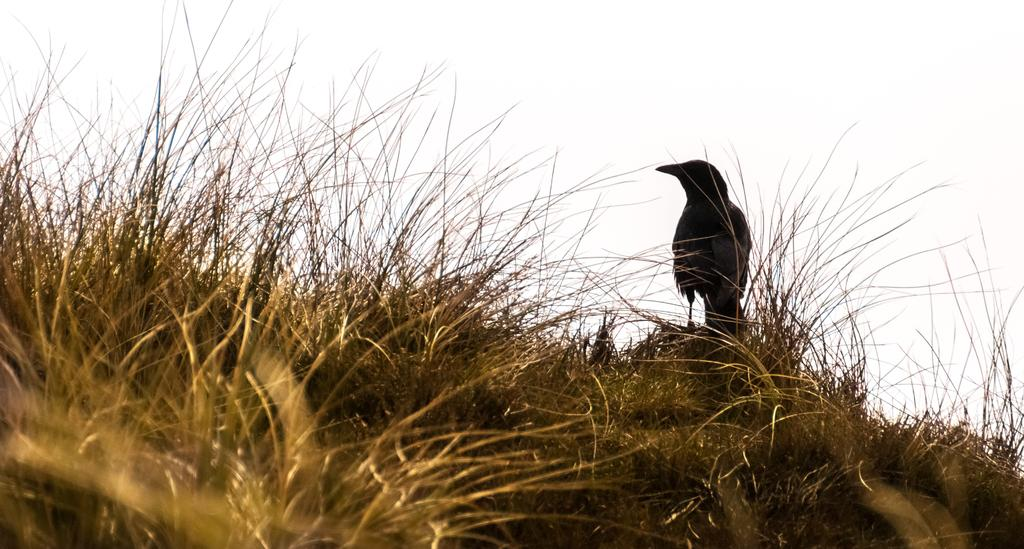What type of animal is in the image? There is a bird in the image. Where is the bird located? The bird is on dry grass. What can be seen in the background of the image? The sky is visible in the background of the image. What type of quartz can be seen in the bird's beak in the image? There is no quartz present in the image, and the bird's beak is not visible. How does the bird's knee bend in the image? Birds do not have knees like humans, and the bird's legs are not visible in the image. 